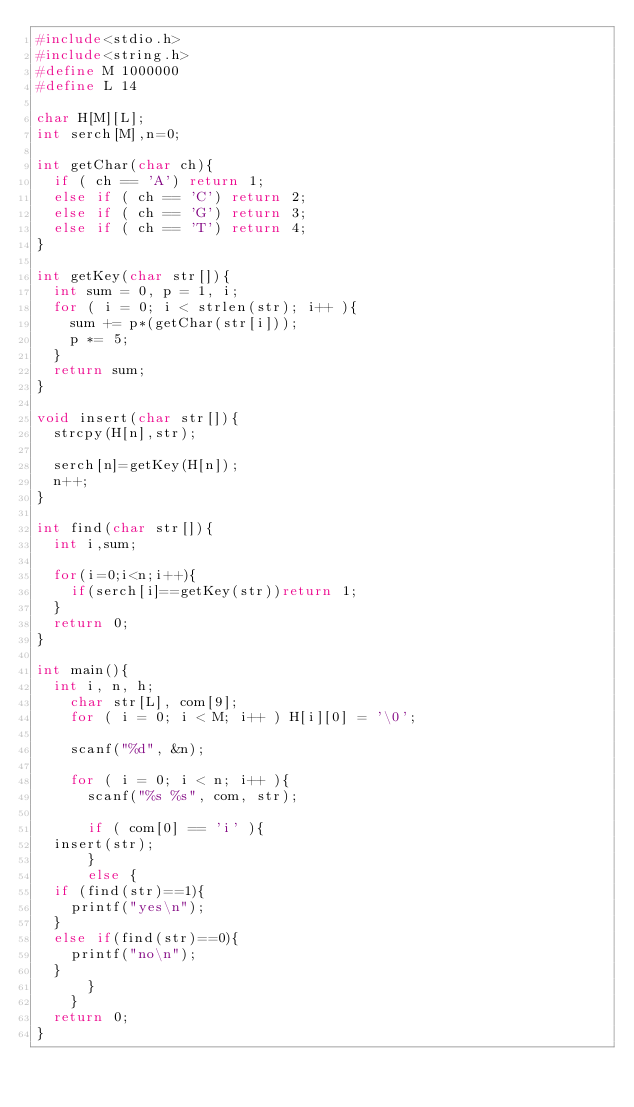Convert code to text. <code><loc_0><loc_0><loc_500><loc_500><_C_>#include<stdio.h>
#include<string.h>
#define M 1000000
#define L 14

char H[M][L];
int serch[M],n=0;

int getChar(char ch){
  if ( ch == 'A') return 1;
  else if ( ch == 'C') return 2;
  else if ( ch == 'G') return 3;
  else if ( ch == 'T') return 4;
}

int getKey(char str[]){
  int sum = 0, p = 1, i;
  for ( i = 0; i < strlen(str); i++ ){
    sum += p*(getChar(str[i]));
    p *= 5;
  }
  return sum;
}

void insert(char str[]){
  strcpy(H[n],str);
  
  serch[n]=getKey(H[n]);
  n++;
}

int find(char str[]){
  int i,sum;
  
  for(i=0;i<n;i++){
    if(serch[i]==getKey(str))return 1;
  }
  return 0;
}

int main(){
  int i, n, h;
    char str[L], com[9];
    for ( i = 0; i < M; i++ ) H[i][0] = '\0';
    
    scanf("%d", &n);
    
    for ( i = 0; i < n; i++ ){
      scanf("%s %s", com, str);
      
      if ( com[0] == 'i' ){
	insert(str);
      } 
      else {
	if (find(str)==1){
	  printf("yes\n");
	} 
	else if(find(str)==0){
	  printf("no\n");
	}
      }
    }
  return 0;
}</code> 